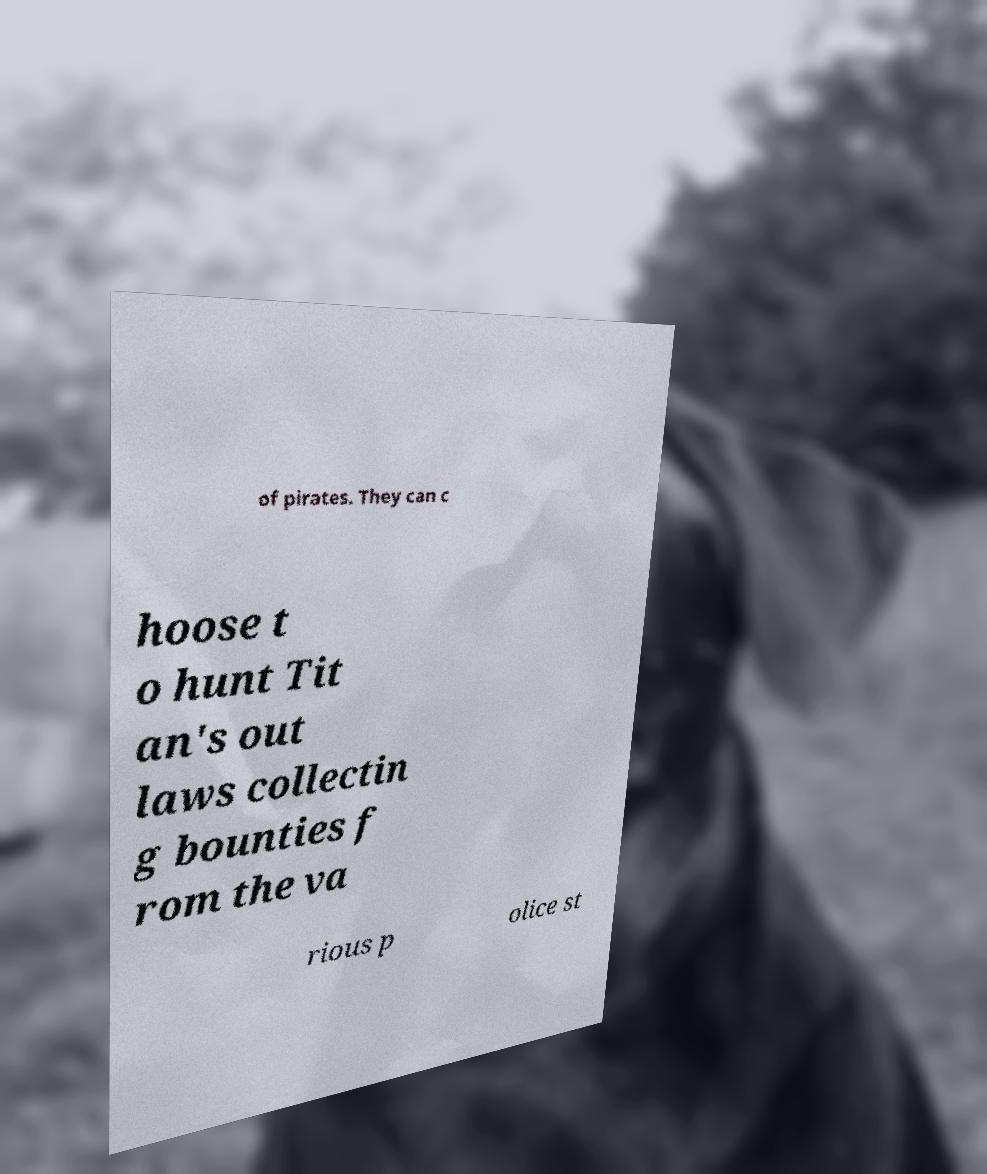Can you read and provide the text displayed in the image?This photo seems to have some interesting text. Can you extract and type it out for me? of pirates. They can c hoose t o hunt Tit an's out laws collectin g bounties f rom the va rious p olice st 